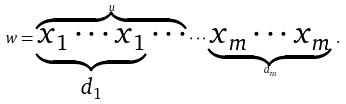<formula> <loc_0><loc_0><loc_500><loc_500>w = \overbrace { \underbrace { x _ { 1 } \cdots x _ { 1 } } _ { d _ { 1 } } \cdots } ^ { u } \cdots \underbrace { x _ { m } \cdots x _ { m } } _ { d _ { m } } \, .</formula> 